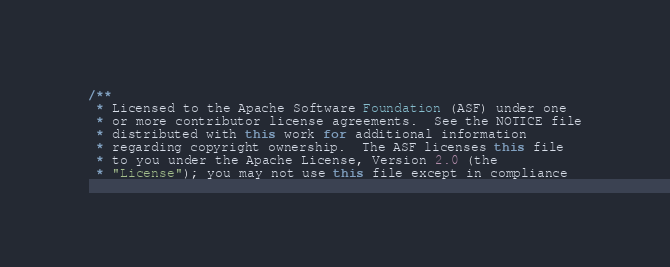Convert code to text. <code><loc_0><loc_0><loc_500><loc_500><_Java_>/**
 * Licensed to the Apache Software Foundation (ASF) under one
 * or more contributor license agreements.  See the NOTICE file
 * distributed with this work for additional information
 * regarding copyright ownership.  The ASF licenses this file
 * to you under the Apache License, Version 2.0 (the
 * "License"); you may not use this file except in compliance</code> 